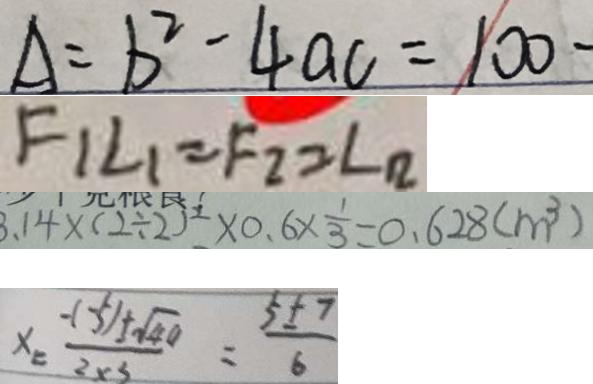Convert formula to latex. <formula><loc_0><loc_0><loc_500><loc_500>A = b ^ { 2 } - 4 a c = 1 0 0 - 
 F _ { 1 } L _ { 1 } = F _ { 2 } = \angle _ { 2 } 
 3 . 1 4 \times ( 2 \div 2 ) ^ { 2 } \times 0 . 6 \times \frac { 1 } { 3 } = 0 . 6 2 8 ( m ^ { 3 } ) 
 x = \frac { - ( - 5 ) \pm \sqrt { 4 0 } } { 2 \times 3 } = \frac { 5 \pm 7 } { 6 }</formula> 